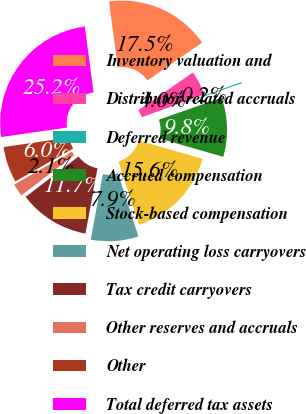Convert chart. <chart><loc_0><loc_0><loc_500><loc_500><pie_chart><fcel>Inventory valuation and<fcel>Distributor related accruals<fcel>Deferred revenue<fcel>Accrued compensation<fcel>Stock-based compensation<fcel>Net operating loss carryovers<fcel>Tax credit carryovers<fcel>Other reserves and accruals<fcel>Other<fcel>Total deferred tax assets<nl><fcel>17.49%<fcel>4.05%<fcel>0.21%<fcel>9.81%<fcel>15.57%<fcel>7.89%<fcel>11.73%<fcel>2.13%<fcel>5.97%<fcel>25.17%<nl></chart> 